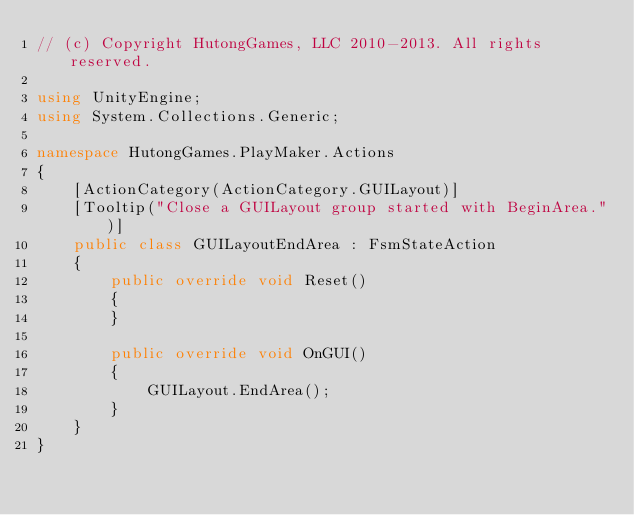Convert code to text. <code><loc_0><loc_0><loc_500><loc_500><_C#_>// (c) Copyright HutongGames, LLC 2010-2013. All rights reserved.

using UnityEngine;
using System.Collections.Generic;

namespace HutongGames.PlayMaker.Actions
{
	[ActionCategory(ActionCategory.GUILayout)]
	[Tooltip("Close a GUILayout group started with BeginArea.")]
	public class GUILayoutEndArea : FsmStateAction
	{
		public override void Reset()
		{
		}

		public override void OnGUI()
		{
			GUILayout.EndArea();
		}
	}
}</code> 